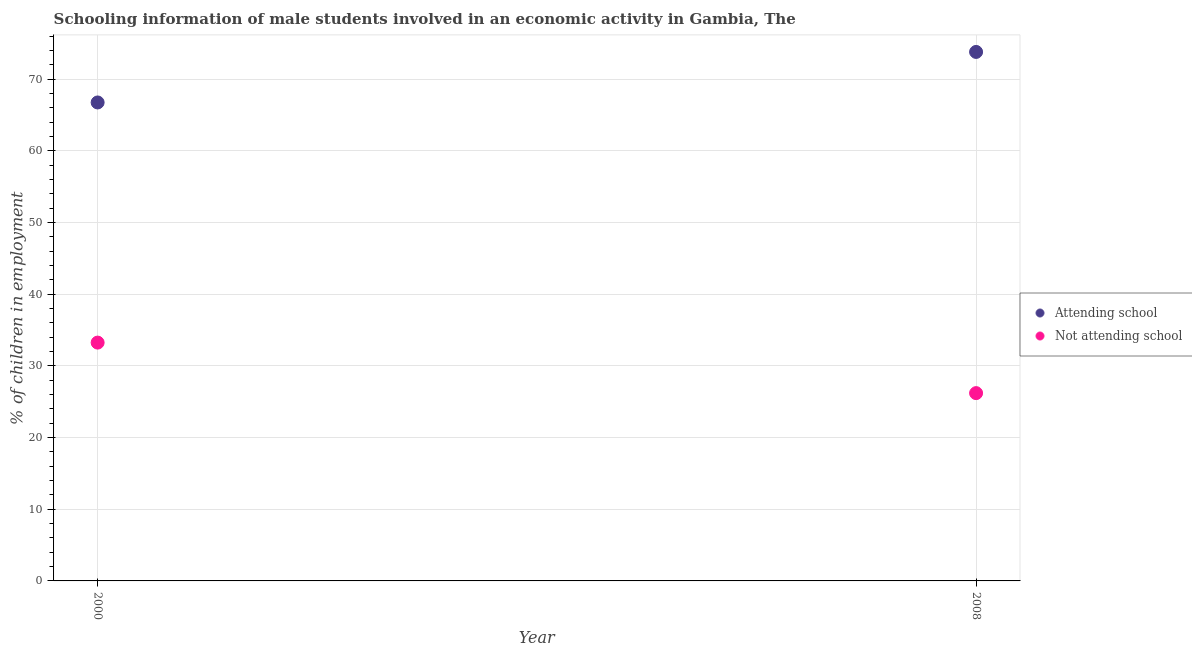What is the percentage of employed males who are not attending school in 2008?
Keep it short and to the point. 26.2. Across all years, what is the maximum percentage of employed males who are not attending school?
Provide a short and direct response. 33.25. Across all years, what is the minimum percentage of employed males who are not attending school?
Provide a succinct answer. 26.2. What is the total percentage of employed males who are attending school in the graph?
Offer a terse response. 140.55. What is the difference between the percentage of employed males who are attending school in 2000 and that in 2008?
Keep it short and to the point. -7.05. What is the difference between the percentage of employed males who are attending school in 2000 and the percentage of employed males who are not attending school in 2008?
Keep it short and to the point. 40.55. What is the average percentage of employed males who are attending school per year?
Ensure brevity in your answer.  70.28. In the year 2000, what is the difference between the percentage of employed males who are attending school and percentage of employed males who are not attending school?
Ensure brevity in your answer.  33.5. What is the ratio of the percentage of employed males who are not attending school in 2000 to that in 2008?
Make the answer very short. 1.27. In how many years, is the percentage of employed males who are not attending school greater than the average percentage of employed males who are not attending school taken over all years?
Keep it short and to the point. 1. Is the percentage of employed males who are attending school strictly less than the percentage of employed males who are not attending school over the years?
Provide a short and direct response. No. What is the difference between two consecutive major ticks on the Y-axis?
Make the answer very short. 10. Are the values on the major ticks of Y-axis written in scientific E-notation?
Your answer should be very brief. No. Does the graph contain grids?
Keep it short and to the point. Yes. Where does the legend appear in the graph?
Keep it short and to the point. Center right. How are the legend labels stacked?
Offer a very short reply. Vertical. What is the title of the graph?
Ensure brevity in your answer.  Schooling information of male students involved in an economic activity in Gambia, The. Does "Crop" appear as one of the legend labels in the graph?
Your response must be concise. No. What is the label or title of the Y-axis?
Keep it short and to the point. % of children in employment. What is the % of children in employment of Attending school in 2000?
Keep it short and to the point. 66.75. What is the % of children in employment of Not attending school in 2000?
Offer a very short reply. 33.25. What is the % of children in employment of Attending school in 2008?
Ensure brevity in your answer.  73.8. What is the % of children in employment in Not attending school in 2008?
Your response must be concise. 26.2. Across all years, what is the maximum % of children in employment in Attending school?
Offer a terse response. 73.8. Across all years, what is the maximum % of children in employment of Not attending school?
Ensure brevity in your answer.  33.25. Across all years, what is the minimum % of children in employment of Attending school?
Give a very brief answer. 66.75. Across all years, what is the minimum % of children in employment of Not attending school?
Keep it short and to the point. 26.2. What is the total % of children in employment of Attending school in the graph?
Offer a terse response. 140.55. What is the total % of children in employment of Not attending school in the graph?
Give a very brief answer. 59.45. What is the difference between the % of children in employment in Attending school in 2000 and that in 2008?
Your answer should be very brief. -7.05. What is the difference between the % of children in employment of Not attending school in 2000 and that in 2008?
Your answer should be very brief. 7.05. What is the difference between the % of children in employment of Attending school in 2000 and the % of children in employment of Not attending school in 2008?
Your response must be concise. 40.55. What is the average % of children in employment in Attending school per year?
Give a very brief answer. 70.28. What is the average % of children in employment of Not attending school per year?
Provide a succinct answer. 29.72. In the year 2000, what is the difference between the % of children in employment of Attending school and % of children in employment of Not attending school?
Make the answer very short. 33.5. In the year 2008, what is the difference between the % of children in employment in Attending school and % of children in employment in Not attending school?
Offer a very short reply. 47.6. What is the ratio of the % of children in employment in Attending school in 2000 to that in 2008?
Offer a very short reply. 0.9. What is the ratio of the % of children in employment in Not attending school in 2000 to that in 2008?
Ensure brevity in your answer.  1.27. What is the difference between the highest and the second highest % of children in employment in Attending school?
Keep it short and to the point. 7.05. What is the difference between the highest and the second highest % of children in employment in Not attending school?
Provide a short and direct response. 7.05. What is the difference between the highest and the lowest % of children in employment of Attending school?
Your answer should be compact. 7.05. What is the difference between the highest and the lowest % of children in employment in Not attending school?
Your answer should be compact. 7.05. 